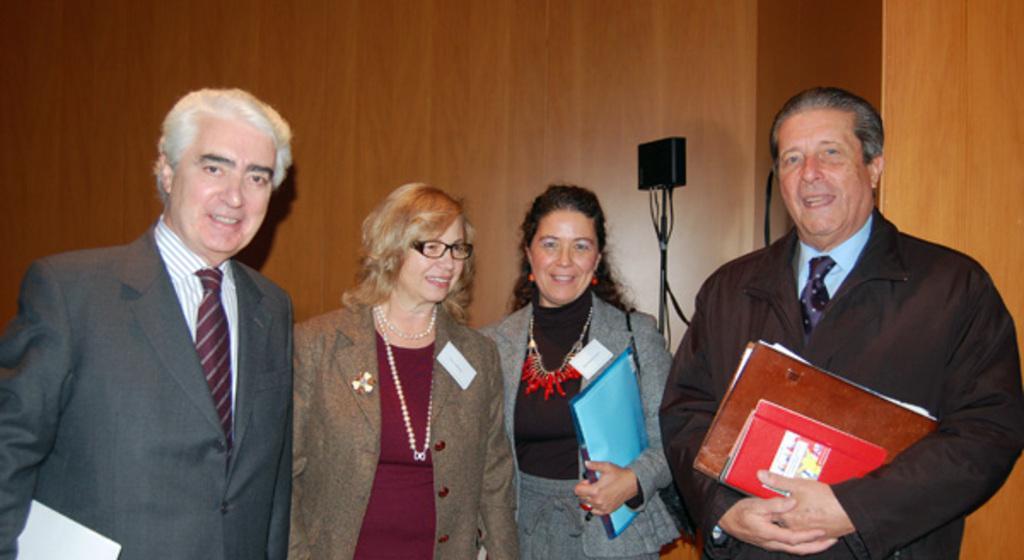Please provide a concise description of this image. In the foreground of the picture there are two men and two women, behind them there is a mic. In the background it is well. 